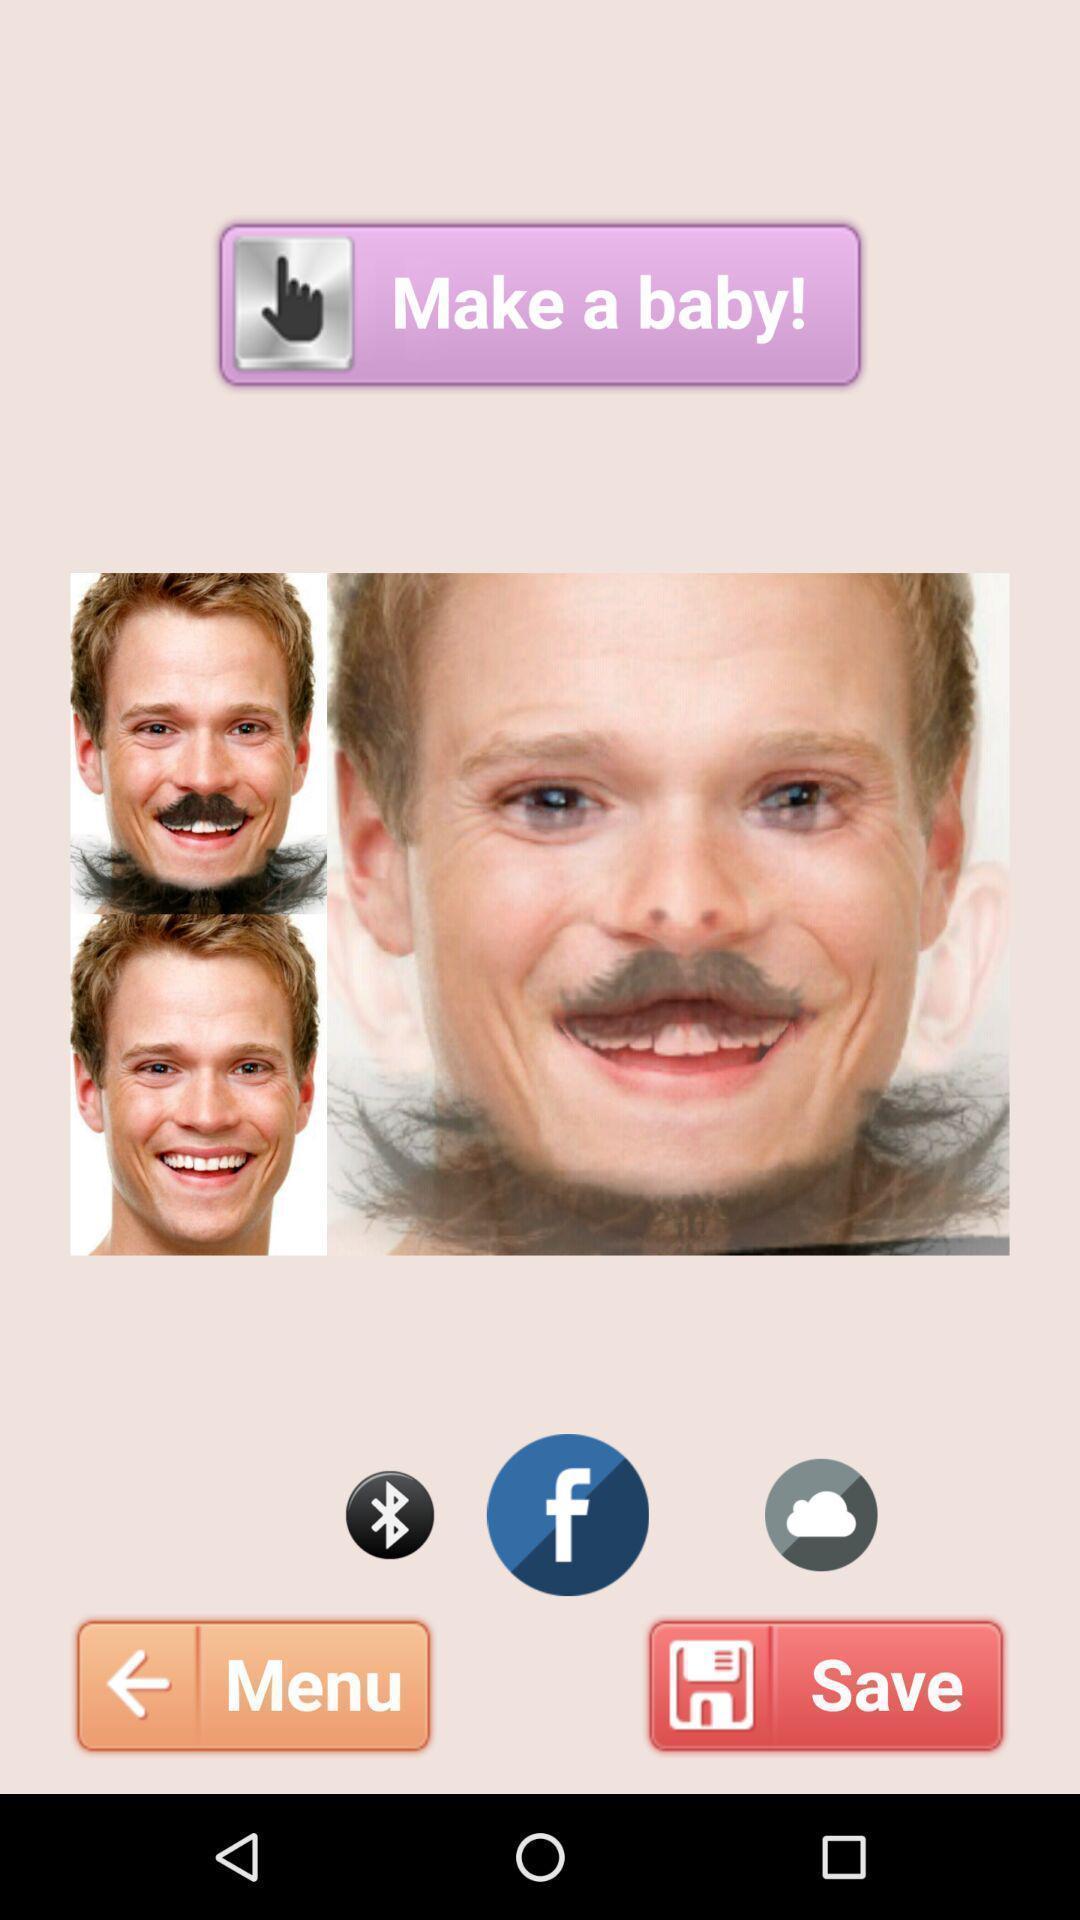Give me a summary of this screen capture. Screen shows photo editor app with multiple options. 